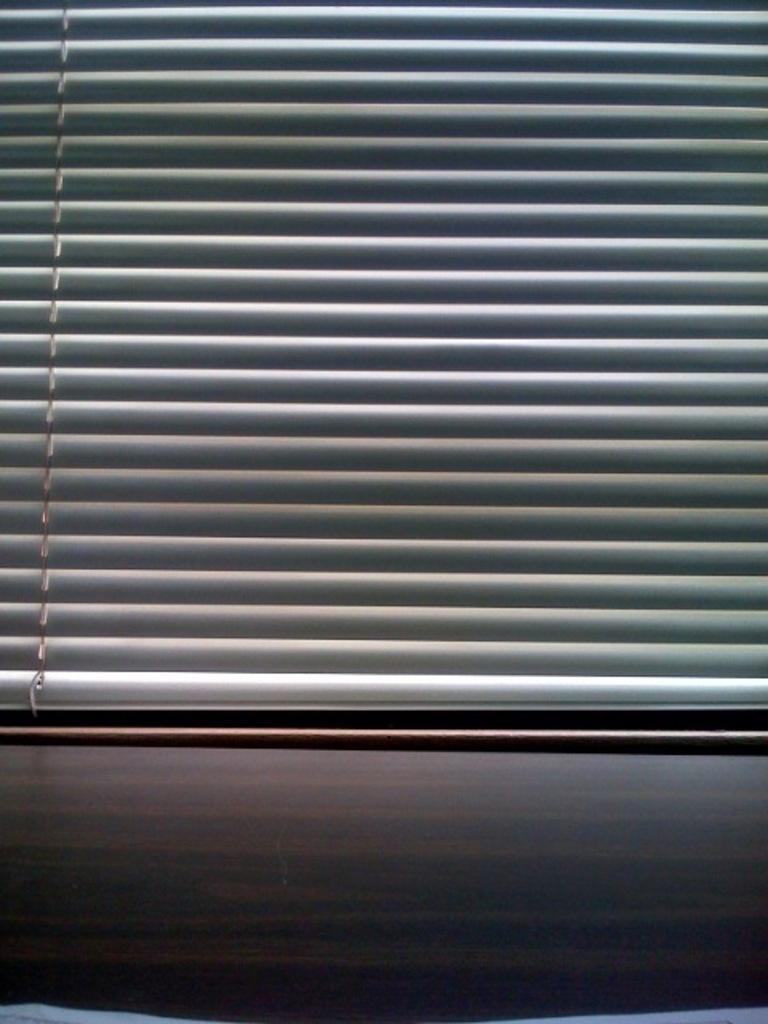Describe this image in one or two sentences. In this picture I can see a window blind. 